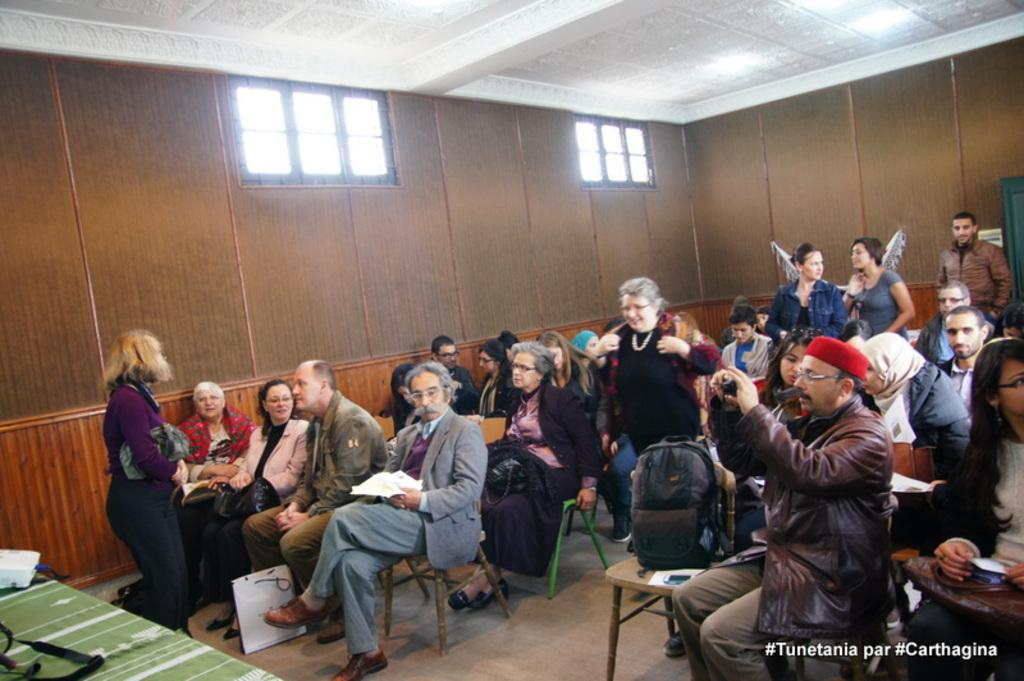What are the people in the image doing? The people in the image are sitting in the room. What are the people sitting on? The people are sitting on chairs. What can be seen on the walls of the room? There are windows in the walls of the room. What color is the roof of the room? The roof of the room is white. What type of fact can be seen in the image? There is no fact present in the image; it features people sitting in a room with chairs, windows, and a white roof. Can you tell me how many porters are visible in the image? There are no porters present in the image. 